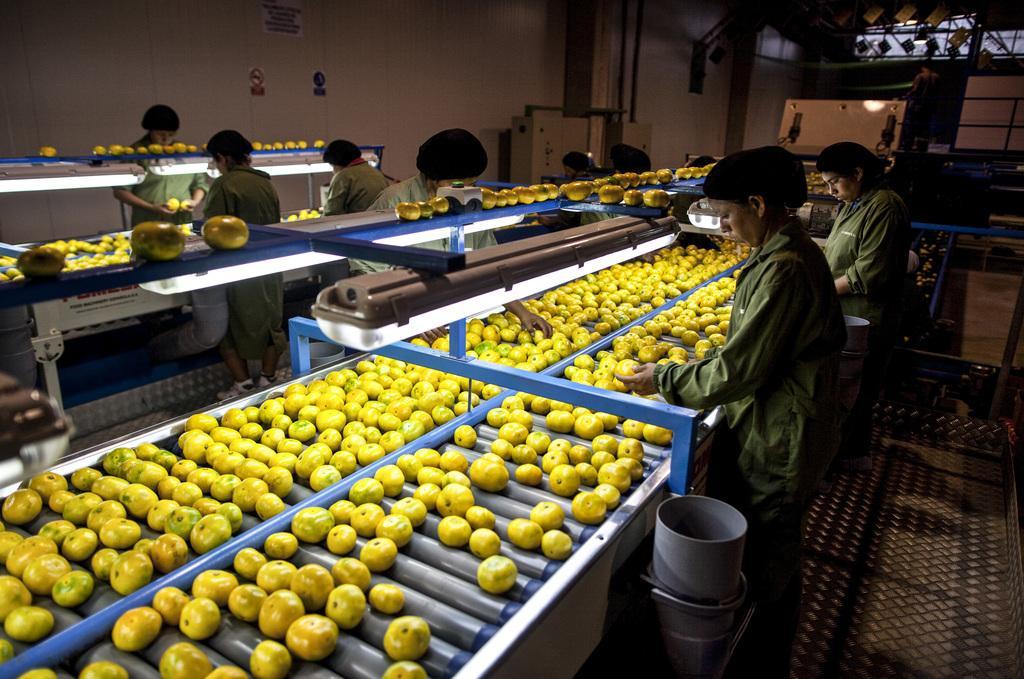Please provide a concise description of this image. In this image there are some people standing, and some of them are holding fruits and some of them are checking the fruits. In the center there are some tables, and on the table there are some fruits and in the background also there are some tables. On the tables there are some fruits, and in the background there is a wall and some objects, grills, light and at the top of the image there are some posters on the wall. And at the bottom of the image there is pipe. 